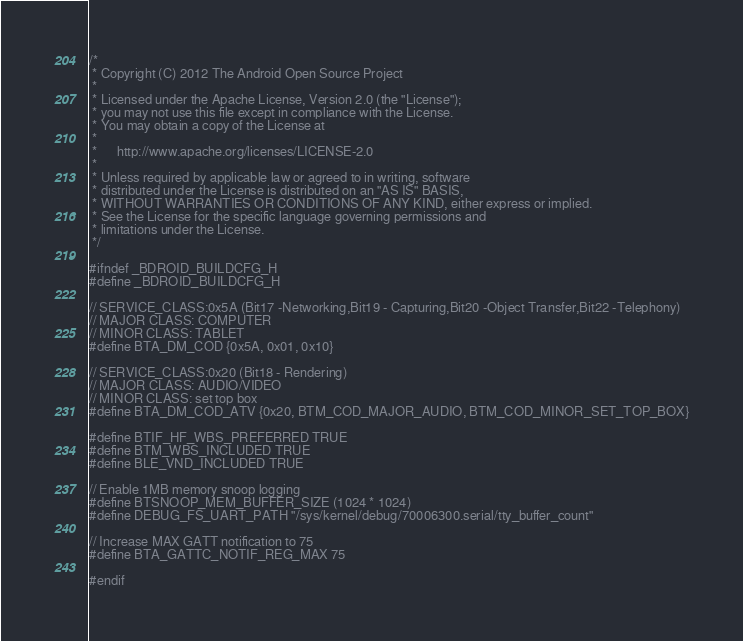Convert code to text. <code><loc_0><loc_0><loc_500><loc_500><_C_>/*
 * Copyright (C) 2012 The Android Open Source Project
 *
 * Licensed under the Apache License, Version 2.0 (the "License");
 * you may not use this file except in compliance with the License.
 * You may obtain a copy of the License at
 *
 *      http://www.apache.org/licenses/LICENSE-2.0
 *
 * Unless required by applicable law or agreed to in writing, software
 * distributed under the License is distributed on an "AS IS" BASIS,
 * WITHOUT WARRANTIES OR CONDITIONS OF ANY KIND, either express or implied.
 * See the License for the specific language governing permissions and
 * limitations under the License.
 */

#ifndef _BDROID_BUILDCFG_H
#define _BDROID_BUILDCFG_H

// SERVICE_CLASS:0x5A (Bit17 -Networking,Bit19 - Capturing,Bit20 -Object Transfer,Bit22 -Telephony)
// MAJOR CLASS: COMPUTER
// MINOR CLASS: TABLET
#define BTA_DM_COD {0x5A, 0x01, 0x10}

// SERVICE_CLASS:0x20 (Bit18 - Rendering)
// MAJOR CLASS: AUDIO/VIDEO
// MINOR CLASS: set top box
#define BTA_DM_COD_ATV {0x20, BTM_COD_MAJOR_AUDIO, BTM_COD_MINOR_SET_TOP_BOX}

#define BTIF_HF_WBS_PREFERRED TRUE
#define BTM_WBS_INCLUDED TRUE
#define BLE_VND_INCLUDED TRUE

// Enable 1MB memory snoop logging
#define BTSNOOP_MEM_BUFFER_SIZE (1024 * 1024)
#define DEBUG_FS_UART_PATH "/sys/kernel/debug/70006300.serial/tty_buffer_count"

// Increase MAX GATT notification to 75
#define BTA_GATTC_NOTIF_REG_MAX 75

#endif
</code> 